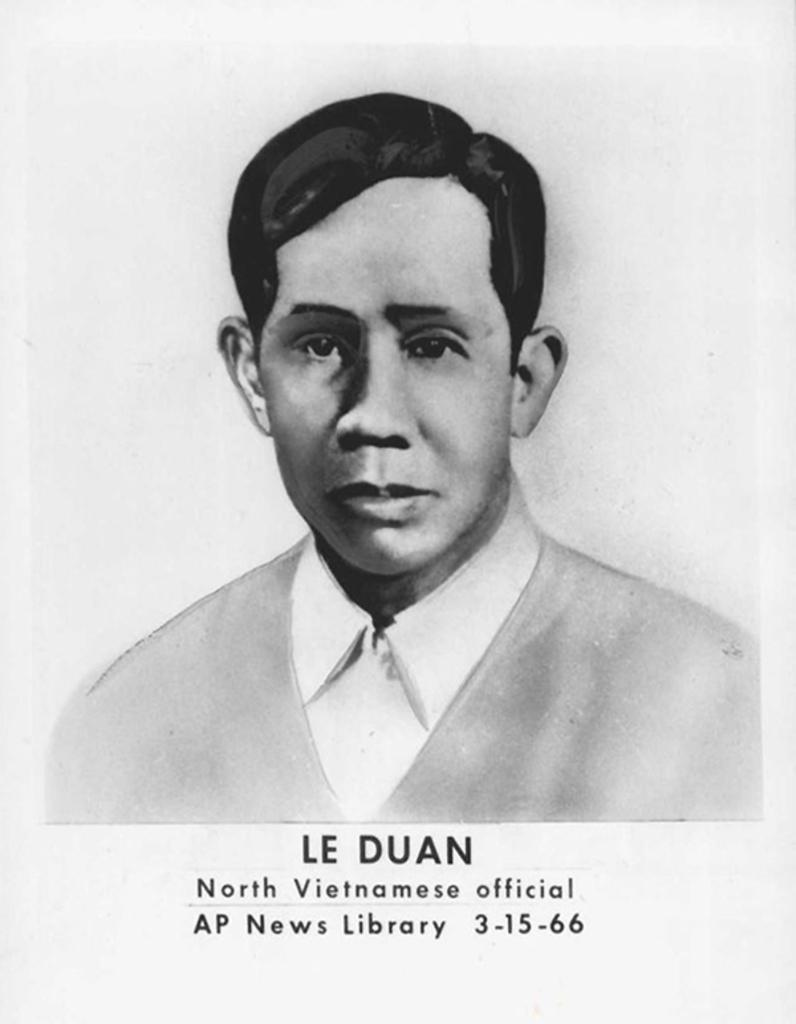What is the main subject of the poster in the image? The poster features a person. What else can be seen on the poster besides the person? There is text written on the poster. How many eyes can be seen on the furniture in the image? There is no furniture present in the image, and therefore no eyes can be seen on any furniture. 